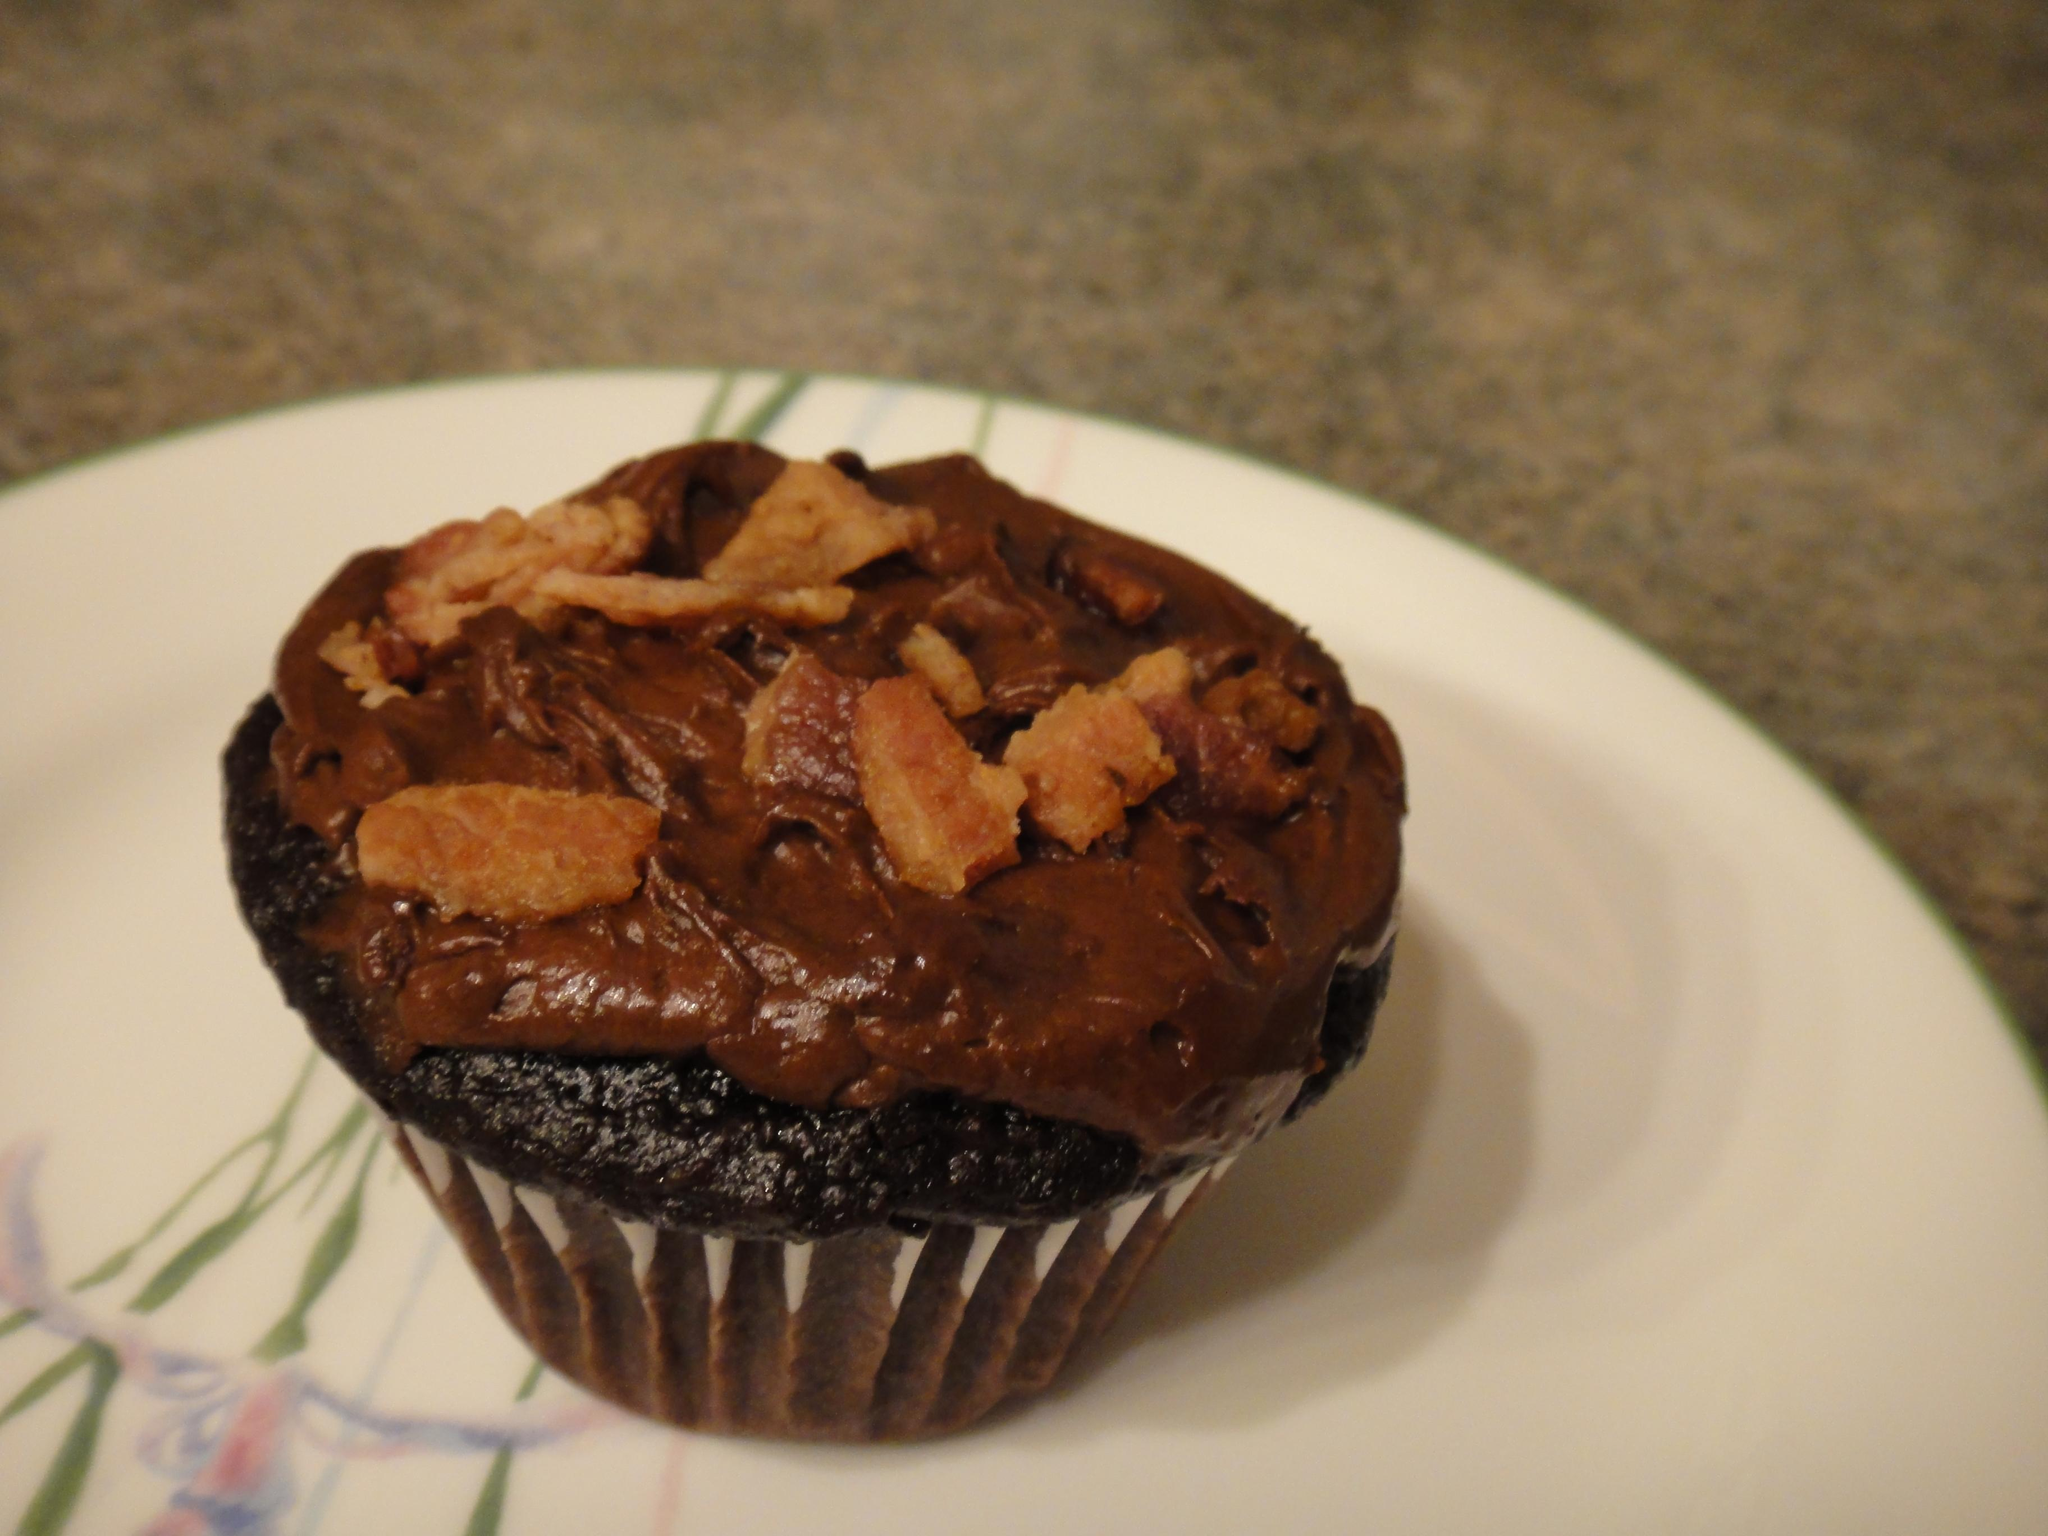What is on the plate that is visible in the image? The plate has a cupcake on it. Where is the plate located in the image? The plate is placed on a stone slab. What type of advertisement can be seen on the gate in the image? There is no gate or advertisement present in the image. 